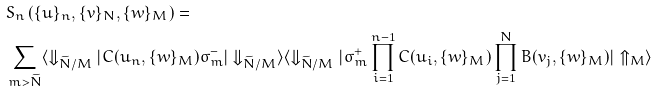Convert formula to latex. <formula><loc_0><loc_0><loc_500><loc_500>& S _ { n } \left ( \{ u \} _ { n } , \{ v \} _ { N } , \{ w \} _ { M } \right ) = \\ & \sum _ { m > \widetilde { N } } \langle \Downarrow _ { \widetilde { N } / M } | C ( u _ { n } , \{ w \} _ { M } ) \sigma _ { m } ^ { - } | \Downarrow _ { \widetilde { N } / M } \rangle \langle \Downarrow _ { \widetilde { N } / M } | \sigma _ { m } ^ { + } \prod _ { i = 1 } ^ { n - 1 } C ( u _ { i } , \{ w \} _ { M } ) \prod _ { j = 1 } ^ { N } B ( v _ { j } , \{ w \} _ { M } ) | \Uparrow _ { M } \rangle</formula> 